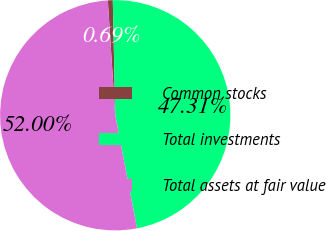<chart> <loc_0><loc_0><loc_500><loc_500><pie_chart><fcel>Common stocks<fcel>Total investments<fcel>Total assets at fair value<nl><fcel>0.69%<fcel>47.31%<fcel>52.0%<nl></chart> 